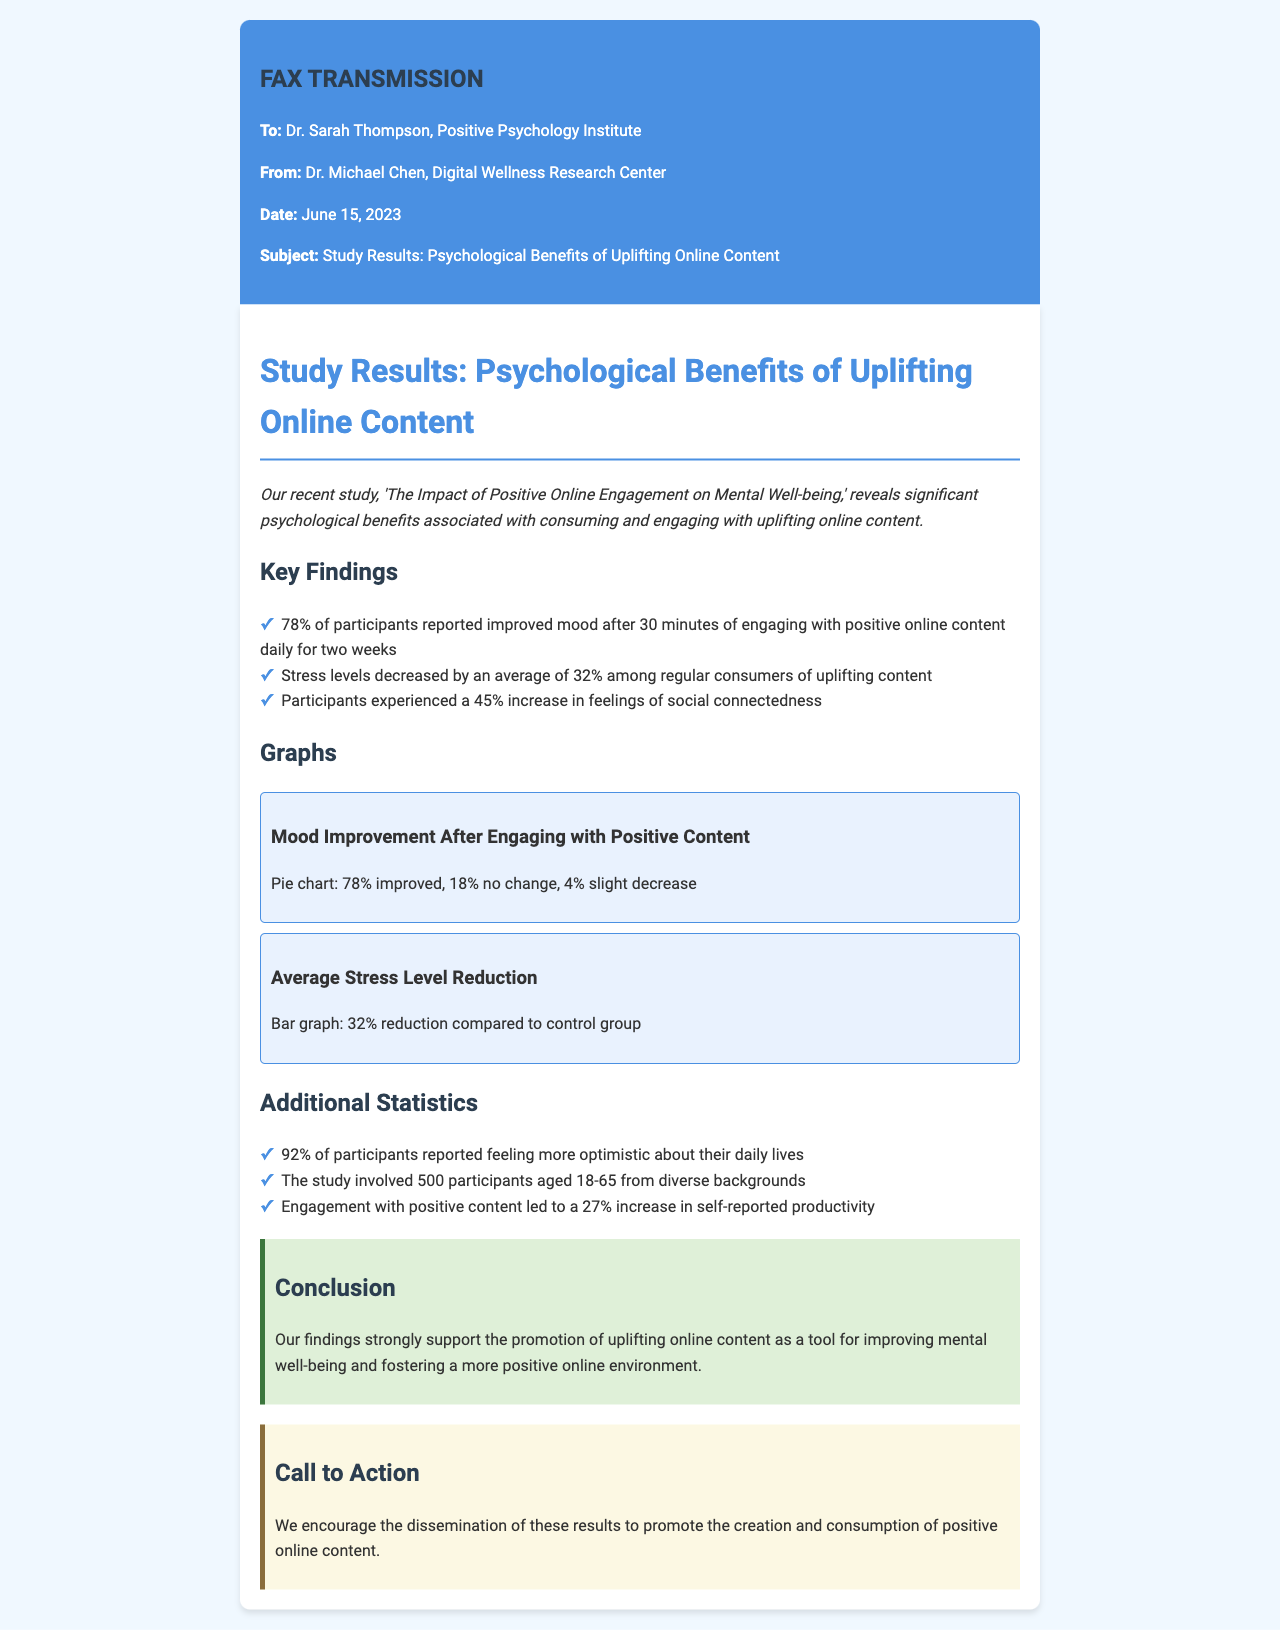What is the title of the study? The title of the study is mentioned at the beginning of the fax.
Answer: The Impact of Positive Online Engagement on Mental Well-being What percentage of participants reported improved mood? The document states that 78% of participants reported improved mood.
Answer: 78% By what percentage did stress levels decrease? The document indicates that stress levels decreased by an average of 32%.
Answer: 32% How many participants were involved in the study? The study involved 500 participants according to the document.
Answer: 500 What is the primary conclusion of the study? The conclusion discusses the support for promoting uplifting online content.
Answer: Improving mental well-being What percentage increase was observed in feelings of social connectedness? The document states participants experienced a 45% increase in feelings of social connectedness.
Answer: 45% What kind of graphs are included in the fax? The document mentions two types of graphs related to mood improvement and stress level reduction.
Answer: Pie chart and Bar graph What was the date of the fax transmission? The date of the fax transmission is specified in the header of the document.
Answer: June 15, 2023 What percentage of participants felt more optimistic about their daily lives? The document states that 92% of participants reported feeling more optimistic.
Answer: 92% 